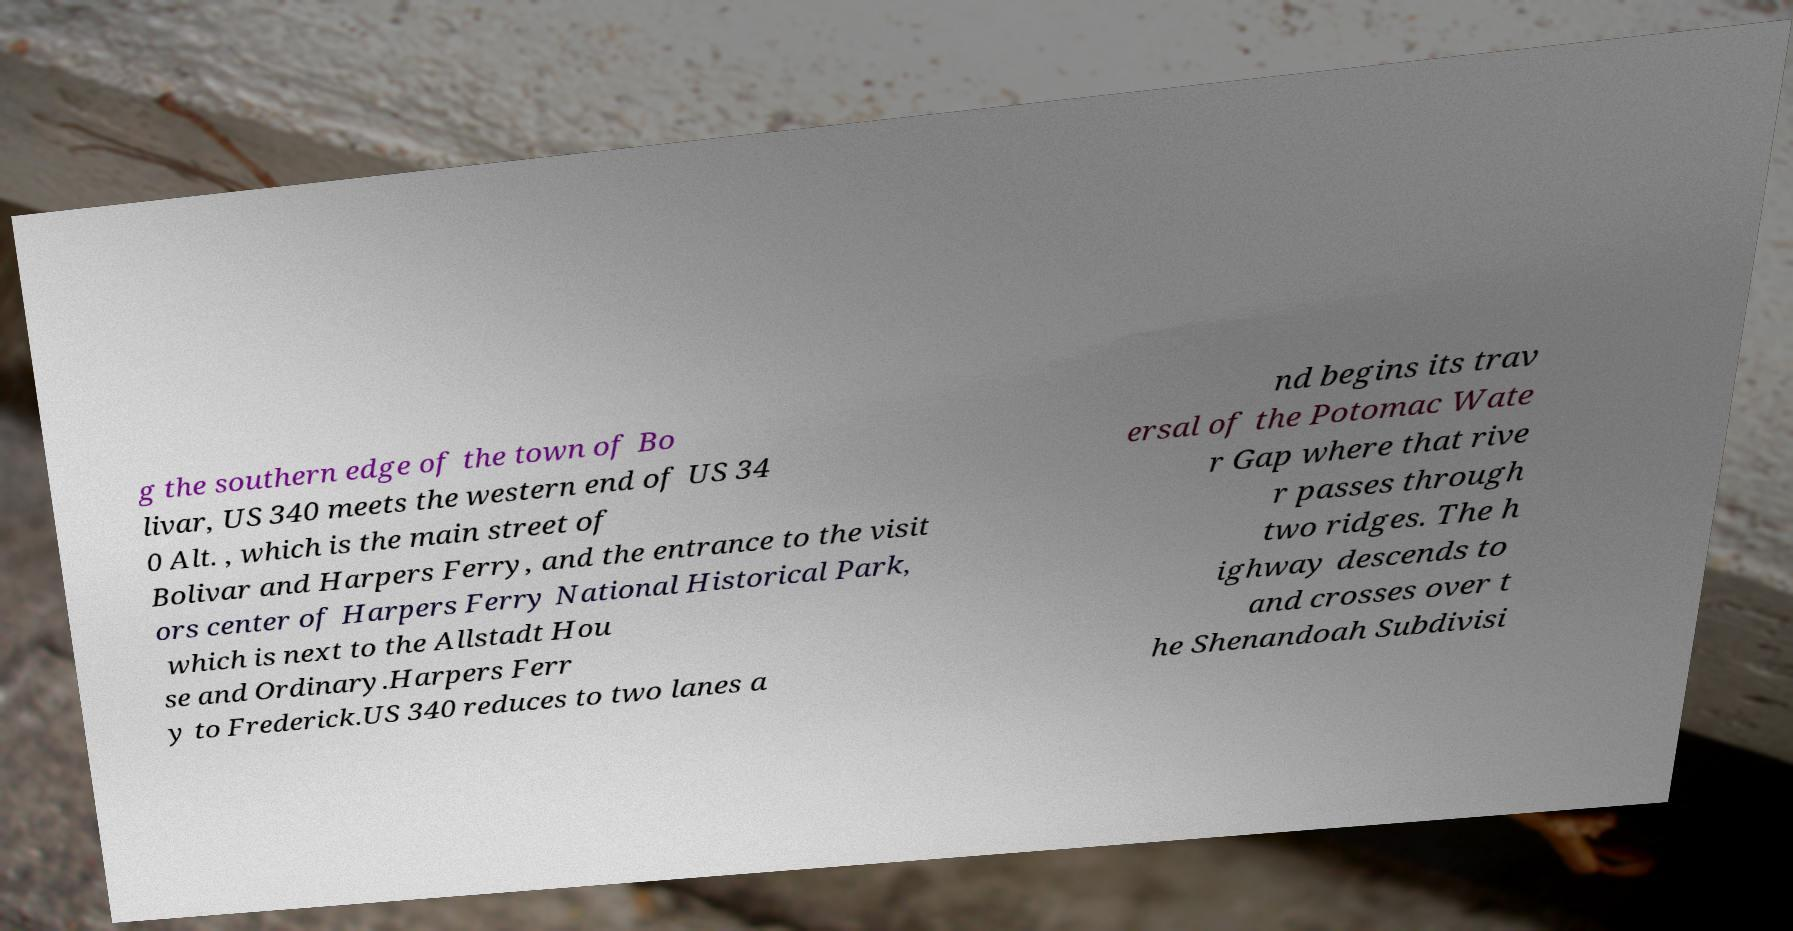Could you assist in decoding the text presented in this image and type it out clearly? g the southern edge of the town of Bo livar, US 340 meets the western end of US 34 0 Alt. , which is the main street of Bolivar and Harpers Ferry, and the entrance to the visit ors center of Harpers Ferry National Historical Park, which is next to the Allstadt Hou se and Ordinary.Harpers Ferr y to Frederick.US 340 reduces to two lanes a nd begins its trav ersal of the Potomac Wate r Gap where that rive r passes through two ridges. The h ighway descends to and crosses over t he Shenandoah Subdivisi 